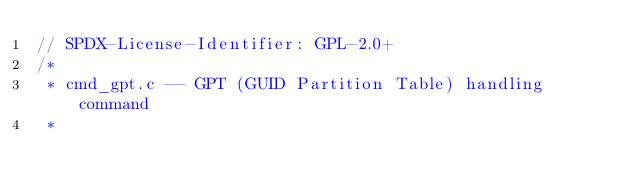Convert code to text. <code><loc_0><loc_0><loc_500><loc_500><_C_>// SPDX-License-Identifier: GPL-2.0+
/*
 * cmd_gpt.c -- GPT (GUID Partition Table) handling command
 *</code> 